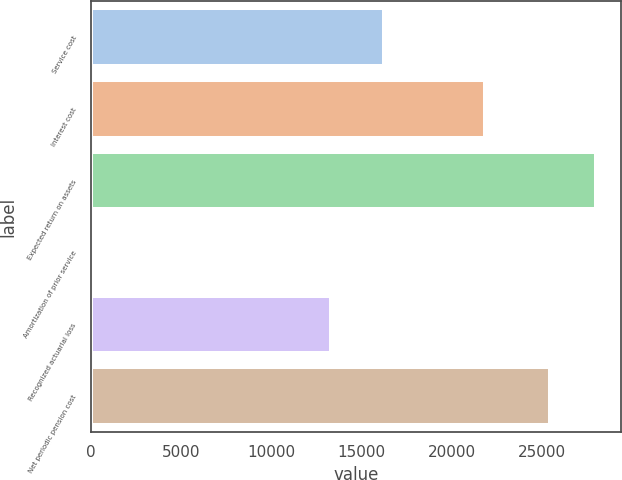<chart> <loc_0><loc_0><loc_500><loc_500><bar_chart><fcel>Service cost<fcel>Interest cost<fcel>Expected return on assets<fcel>Amortization of prior service<fcel>Recognized actuarial loss<fcel>Net periodic pension cost<nl><fcel>16231<fcel>21850<fcel>28022.2<fcel>192<fcel>13322<fcel>25467<nl></chart> 